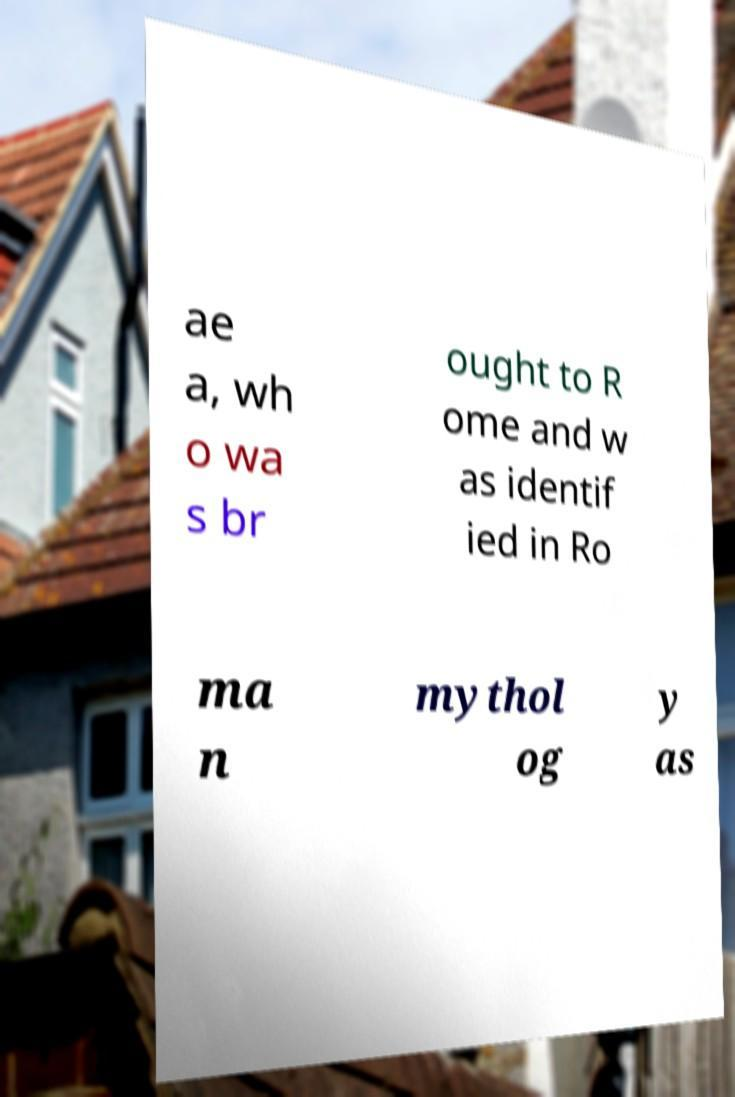I need the written content from this picture converted into text. Can you do that? ae a, wh o wa s br ought to R ome and w as identif ied in Ro ma n mythol og y as 